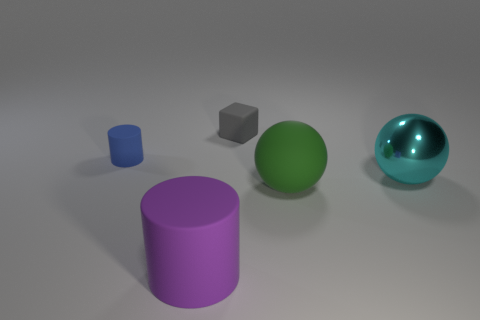Are there any other things that have the same size as the purple rubber cylinder?
Your answer should be compact. Yes. What material is the cylinder to the left of the matte cylinder that is in front of the rubber cylinder that is to the left of the purple matte cylinder?
Offer a very short reply. Rubber. Are there more tiny blue rubber cylinders that are in front of the cyan thing than big green things that are behind the green object?
Provide a succinct answer. No. Do the blue cylinder and the gray rubber thing have the same size?
Provide a short and direct response. Yes. The other thing that is the same shape as the big green rubber thing is what color?
Keep it short and to the point. Cyan. How many big matte balls have the same color as the large matte cylinder?
Make the answer very short. 0. Are there more tiny gray rubber blocks that are behind the purple matte cylinder than cyan spheres?
Provide a short and direct response. No. What is the color of the cylinder that is behind the rubber cylinder that is to the right of the tiny cylinder?
Keep it short and to the point. Blue. What number of things are either small cylinders left of the big purple rubber object or big things in front of the cyan metallic ball?
Make the answer very short. 3. The tiny cylinder has what color?
Make the answer very short. Blue. 